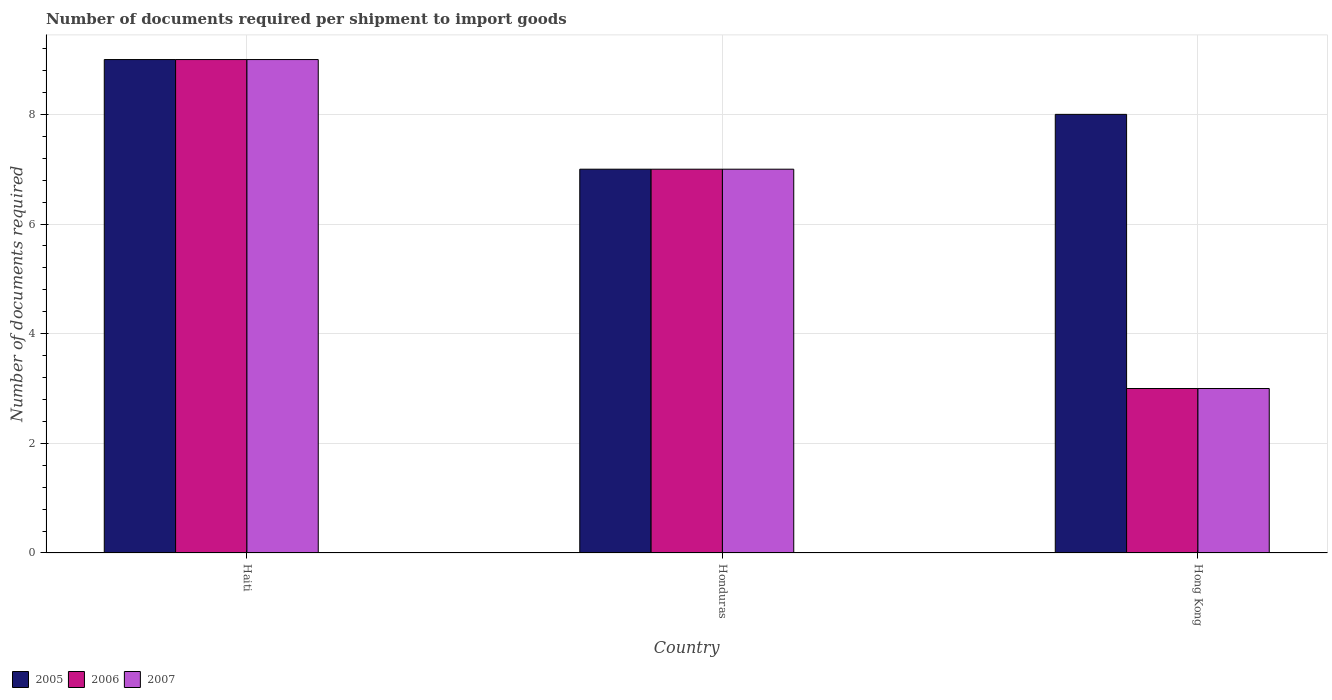Are the number of bars per tick equal to the number of legend labels?
Provide a succinct answer. Yes. What is the label of the 1st group of bars from the left?
Ensure brevity in your answer.  Haiti. What is the number of documents required per shipment to import goods in 2006 in Honduras?
Your response must be concise. 7. In which country was the number of documents required per shipment to import goods in 2007 maximum?
Provide a succinct answer. Haiti. In which country was the number of documents required per shipment to import goods in 2006 minimum?
Your response must be concise. Hong Kong. What is the difference between the number of documents required per shipment to import goods in 2007 in Honduras and that in Hong Kong?
Offer a very short reply. 4. What is the difference between the number of documents required per shipment to import goods in 2006 in Honduras and the number of documents required per shipment to import goods in 2005 in Hong Kong?
Ensure brevity in your answer.  -1. What is the average number of documents required per shipment to import goods in 2007 per country?
Provide a succinct answer. 6.33. In how many countries, is the number of documents required per shipment to import goods in 2007 greater than 6?
Keep it short and to the point. 2. What is the difference between the highest and the second highest number of documents required per shipment to import goods in 2006?
Your answer should be compact. 6. In how many countries, is the number of documents required per shipment to import goods in 2006 greater than the average number of documents required per shipment to import goods in 2006 taken over all countries?
Provide a short and direct response. 2. What does the 1st bar from the left in Hong Kong represents?
Give a very brief answer. 2005. What does the 3rd bar from the right in Hong Kong represents?
Your answer should be very brief. 2005. What is the difference between two consecutive major ticks on the Y-axis?
Make the answer very short. 2. Are the values on the major ticks of Y-axis written in scientific E-notation?
Provide a succinct answer. No. Does the graph contain any zero values?
Make the answer very short. No. Does the graph contain grids?
Your answer should be compact. Yes. How many legend labels are there?
Provide a succinct answer. 3. How are the legend labels stacked?
Ensure brevity in your answer.  Horizontal. What is the title of the graph?
Provide a succinct answer. Number of documents required per shipment to import goods. Does "1978" appear as one of the legend labels in the graph?
Provide a short and direct response. No. What is the label or title of the X-axis?
Your answer should be very brief. Country. What is the label or title of the Y-axis?
Your answer should be very brief. Number of documents required. What is the Number of documents required in 2006 in Haiti?
Keep it short and to the point. 9. What is the Number of documents required of 2007 in Haiti?
Provide a succinct answer. 9. What is the Number of documents required in 2005 in Honduras?
Your response must be concise. 7. What is the Number of documents required of 2006 in Honduras?
Ensure brevity in your answer.  7. What is the Number of documents required of 2007 in Hong Kong?
Ensure brevity in your answer.  3. Across all countries, what is the maximum Number of documents required of 2005?
Your response must be concise. 9. Across all countries, what is the maximum Number of documents required of 2006?
Your answer should be very brief. 9. Across all countries, what is the maximum Number of documents required of 2007?
Your response must be concise. 9. Across all countries, what is the minimum Number of documents required of 2006?
Ensure brevity in your answer.  3. What is the total Number of documents required in 2005 in the graph?
Ensure brevity in your answer.  24. What is the total Number of documents required in 2007 in the graph?
Offer a very short reply. 19. What is the difference between the Number of documents required in 2005 in Haiti and that in Honduras?
Make the answer very short. 2. What is the difference between the Number of documents required in 2006 in Haiti and that in Honduras?
Provide a succinct answer. 2. What is the difference between the Number of documents required in 2007 in Haiti and that in Honduras?
Keep it short and to the point. 2. What is the difference between the Number of documents required of 2005 in Honduras and that in Hong Kong?
Your response must be concise. -1. What is the difference between the Number of documents required in 2005 in Haiti and the Number of documents required in 2006 in Honduras?
Your answer should be compact. 2. What is the difference between the Number of documents required in 2006 in Haiti and the Number of documents required in 2007 in Honduras?
Give a very brief answer. 2. What is the difference between the Number of documents required in 2005 in Haiti and the Number of documents required in 2007 in Hong Kong?
Your response must be concise. 6. What is the difference between the Number of documents required in 2006 in Haiti and the Number of documents required in 2007 in Hong Kong?
Offer a very short reply. 6. What is the average Number of documents required of 2005 per country?
Your answer should be compact. 8. What is the average Number of documents required in 2006 per country?
Your answer should be very brief. 6.33. What is the average Number of documents required of 2007 per country?
Provide a succinct answer. 6.33. What is the difference between the Number of documents required in 2005 and Number of documents required in 2006 in Haiti?
Your answer should be compact. 0. What is the difference between the Number of documents required of 2005 and Number of documents required of 2007 in Haiti?
Give a very brief answer. 0. What is the difference between the Number of documents required of 2006 and Number of documents required of 2007 in Haiti?
Your response must be concise. 0. What is the difference between the Number of documents required of 2005 and Number of documents required of 2007 in Honduras?
Offer a terse response. 0. What is the difference between the Number of documents required in 2005 and Number of documents required in 2006 in Hong Kong?
Offer a very short reply. 5. What is the difference between the Number of documents required of 2005 and Number of documents required of 2007 in Hong Kong?
Offer a terse response. 5. What is the ratio of the Number of documents required in 2006 in Haiti to that in Honduras?
Offer a very short reply. 1.29. What is the ratio of the Number of documents required of 2007 in Haiti to that in Honduras?
Give a very brief answer. 1.29. What is the ratio of the Number of documents required of 2007 in Haiti to that in Hong Kong?
Provide a short and direct response. 3. What is the ratio of the Number of documents required of 2006 in Honduras to that in Hong Kong?
Keep it short and to the point. 2.33. What is the ratio of the Number of documents required in 2007 in Honduras to that in Hong Kong?
Your answer should be compact. 2.33. What is the difference between the highest and the second highest Number of documents required of 2005?
Provide a succinct answer. 1. What is the difference between the highest and the second highest Number of documents required of 2006?
Make the answer very short. 2. What is the difference between the highest and the second highest Number of documents required in 2007?
Offer a very short reply. 2. What is the difference between the highest and the lowest Number of documents required in 2005?
Your answer should be very brief. 2. What is the difference between the highest and the lowest Number of documents required in 2006?
Provide a succinct answer. 6. 